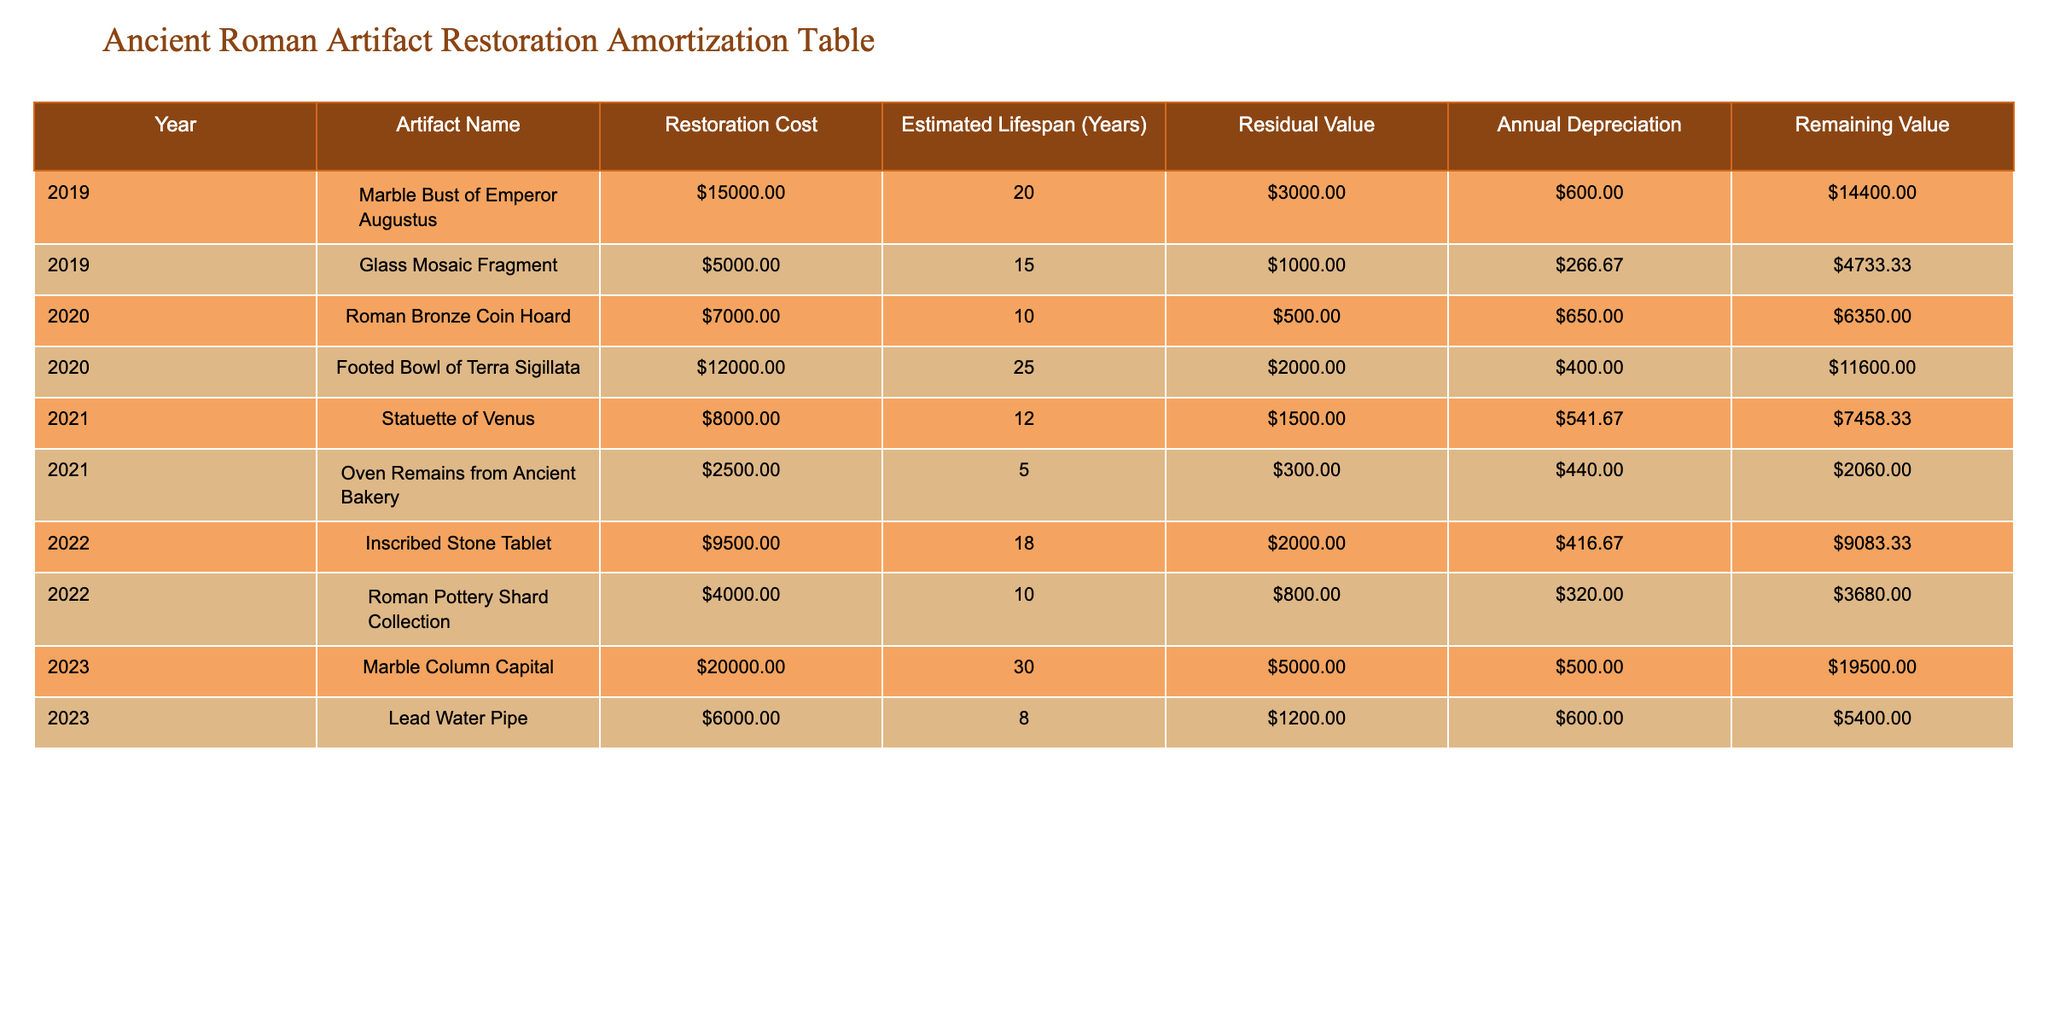What was the restoration cost of the Marble Bust of Emperor Augustus? In the table, I can see the row for the Marble Bust of Emperor Augustus states its restoration cost as 15000.
Answer: 15000 What is the estimated lifespan of the Glass Mosaic Fragment? From the row corresponding to the Glass Mosaic Fragment, I observe its estimated lifespan is 15 years.
Answer: 15 years Which artifact has the highest restoration cost in 2023? Checking the data for 2023, I find two artifacts: the Marble Column Capital at 20000 and the Lead Water Pipe at 6000. Comparing these, the Marble Column Capital has the highest cost.
Answer: Marble Column Capital Is the residual value of the Statuette of Venus lower than 2000? The table shows that the residual value for the Statuette of Venus is 1500, which is indeed lower than 2000.
Answer: Yes What is the total restoration cost for artifacts restored in 2021? The restoration costs for 2021 are the Statuette of Venus at 8000 and the Oven Remains from Ancient Bakery at 2500. I sum these costs: 8000 + 2500 = 10500.
Answer: 10500 What is the average annual depreciation for the Footed Bowl of Terra Sigillata? The restoration cost is 12000, the residual value is 2000, and the lifespan is 25 years. I first find the annual depreciation: (12000 - 2000) / 25 = 400. Hence, the average annual depreciation is 400.
Answer: 400 Are there more artifacts with an estimated lifespan over 20 years than under 10 years? I can identify that the Footed Bowl, Marble Bust of Emperor Augustus, and Marble Column Capital each have a lifespan longer than 20 years, while the Roman Bronze Coin Hoard and Lead Water Pipe have lifespans of less than 10 years. Specifically, 3 artifacts are over 20 years and 2 are under 10 years, therefore it's true that there are more over 20 years.
Answer: Yes What is the remaining value of the Inscribed Stone Tablet after one year of depreciation? The restoration cost for the Inscribed Stone Tablet is 9500 with a residual value of 2000 and a lifespan of 18 years. Its annual depreciation is (9500 - 2000) / 18 ≈ 416.67. After one year, the remaining value is 9500 - 416.67 = 9083.33, which rounds to about 9083.33.
Answer: 9083.33 Which artifact from 2020 has the lowest restoration cost? Looking at the artifacts restored in 2020, the Roman Bronze Coin Hoard costs 7000 and the Footed Bowl costs 12000. The lower value among them is for the Roman Bronze Coin Hoard.
Answer: Roman Bronze Coin Hoard 